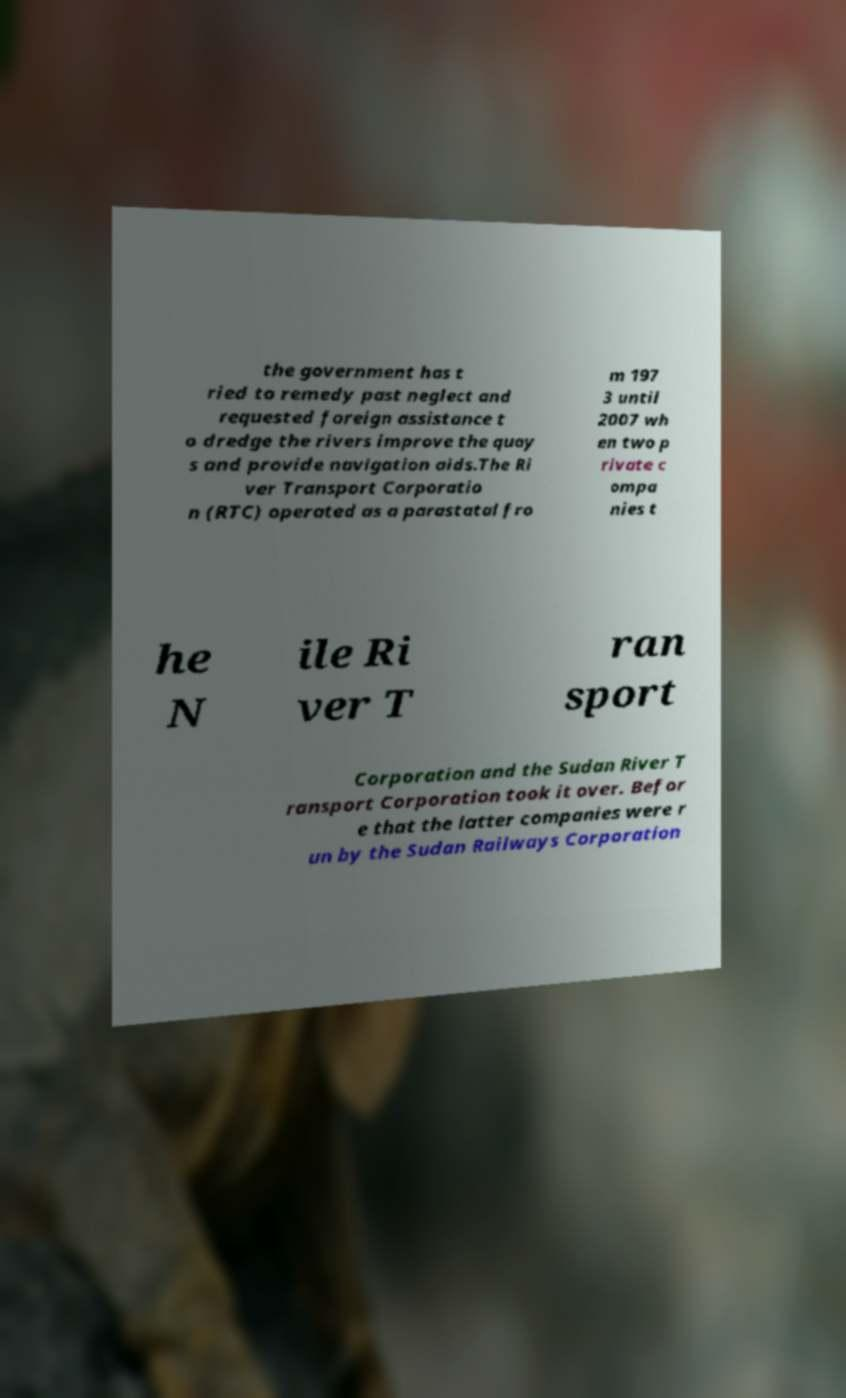Could you extract and type out the text from this image? the government has t ried to remedy past neglect and requested foreign assistance t o dredge the rivers improve the quay s and provide navigation aids.The Ri ver Transport Corporatio n (RTC) operated as a parastatal fro m 197 3 until 2007 wh en two p rivate c ompa nies t he N ile Ri ver T ran sport Corporation and the Sudan River T ransport Corporation took it over. Befor e that the latter companies were r un by the Sudan Railways Corporation 